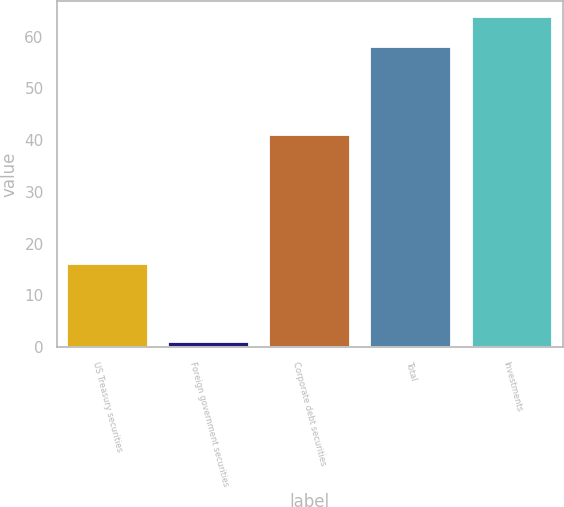<chart> <loc_0><loc_0><loc_500><loc_500><bar_chart><fcel>US Treasury securities<fcel>Foreign government securities<fcel>Corporate debt securities<fcel>Total<fcel>Investments<nl><fcel>16<fcel>1<fcel>41<fcel>58<fcel>63.7<nl></chart> 